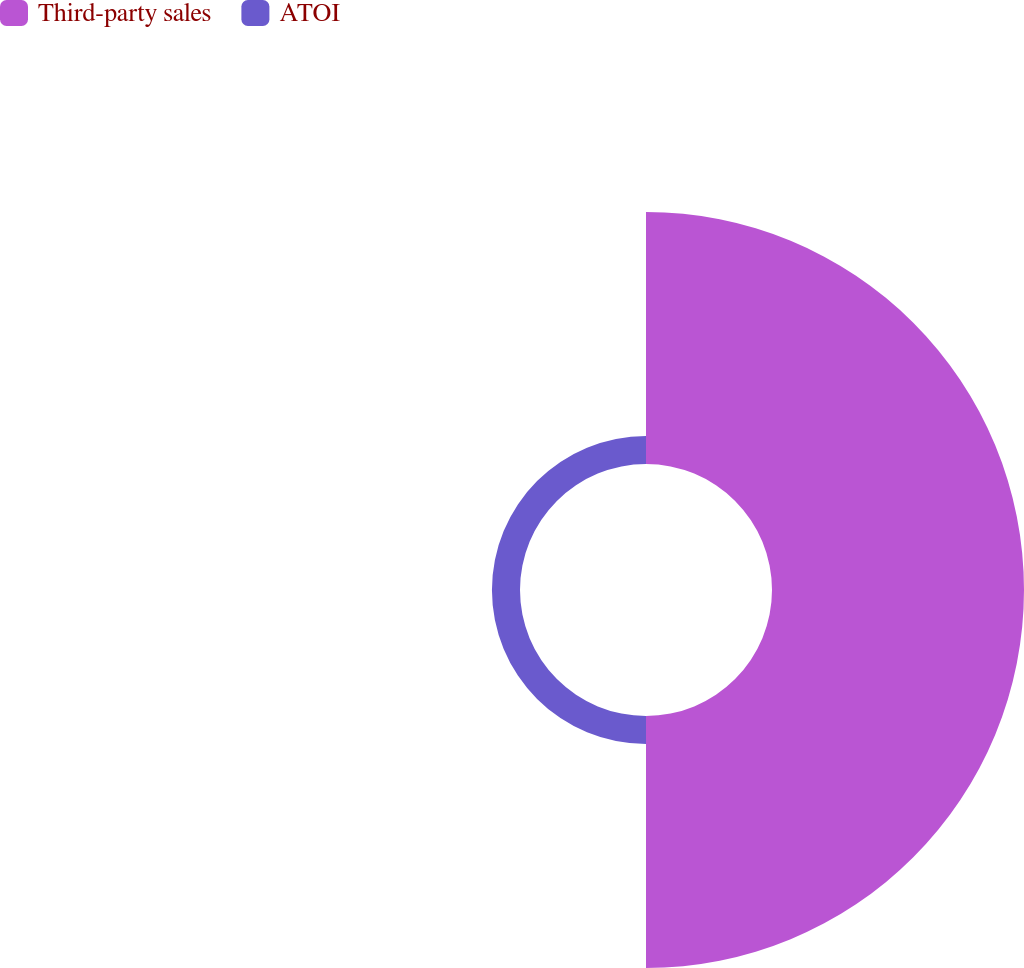Convert chart. <chart><loc_0><loc_0><loc_500><loc_500><pie_chart><fcel>Third-party sales<fcel>ATOI<nl><fcel>89.98%<fcel>10.02%<nl></chart> 